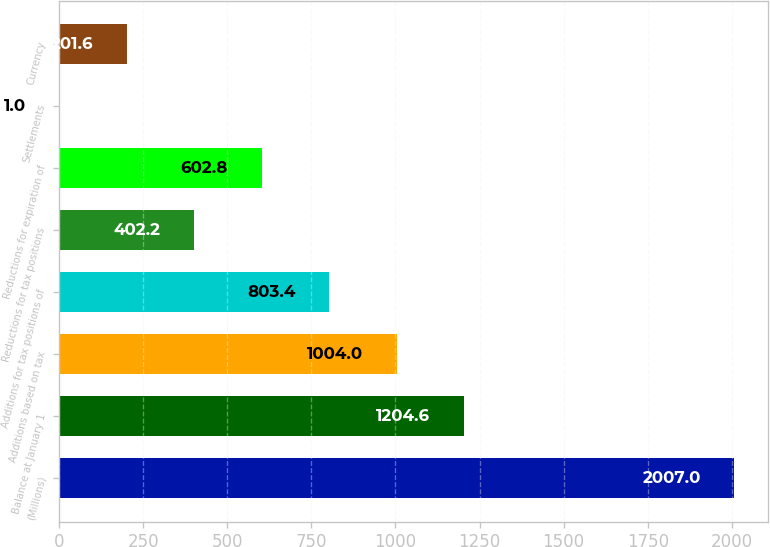<chart> <loc_0><loc_0><loc_500><loc_500><bar_chart><fcel>(Millions)<fcel>Balance at January 1<fcel>Additions based on tax<fcel>Additions for tax positions of<fcel>Reductions for tax positions<fcel>Reductions for expiration of<fcel>Settlements<fcel>Currency<nl><fcel>2007<fcel>1204.6<fcel>1004<fcel>803.4<fcel>402.2<fcel>602.8<fcel>1<fcel>201.6<nl></chart> 